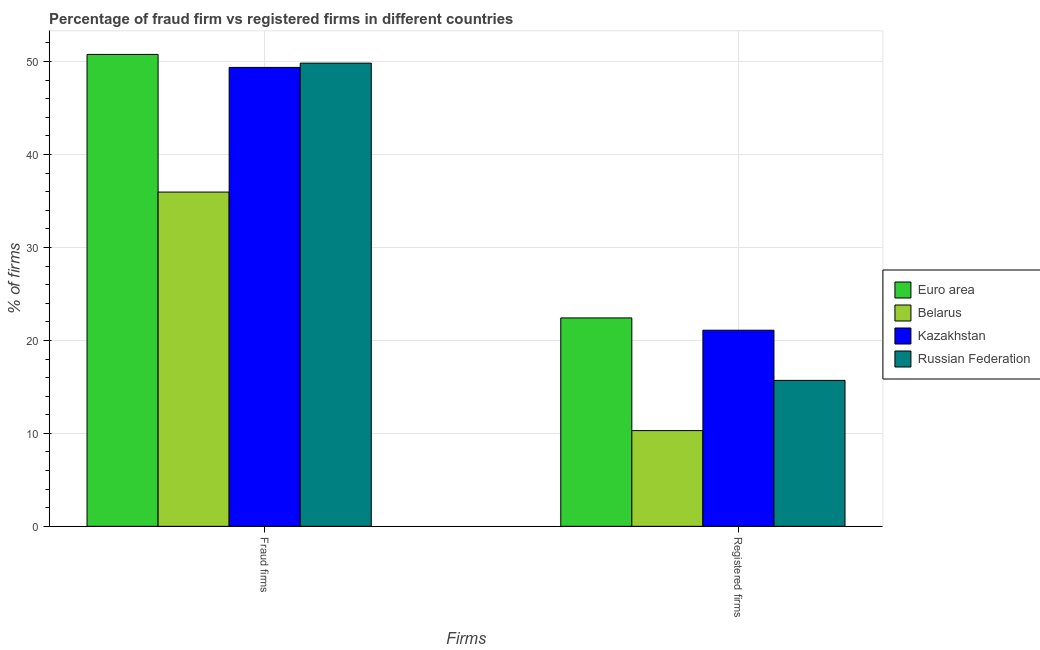How many different coloured bars are there?
Provide a succinct answer. 4. How many groups of bars are there?
Provide a short and direct response. 2. Are the number of bars per tick equal to the number of legend labels?
Provide a succinct answer. Yes. How many bars are there on the 1st tick from the left?
Keep it short and to the point. 4. What is the label of the 1st group of bars from the left?
Provide a short and direct response. Fraud firms. What is the percentage of fraud firms in Belarus?
Your answer should be compact. 35.96. Across all countries, what is the maximum percentage of fraud firms?
Your answer should be compact. 50.77. Across all countries, what is the minimum percentage of fraud firms?
Your answer should be very brief. 35.96. In which country was the percentage of fraud firms maximum?
Give a very brief answer. Euro area. In which country was the percentage of registered firms minimum?
Your answer should be very brief. Belarus. What is the total percentage of registered firms in the graph?
Keep it short and to the point. 69.52. What is the difference between the percentage of fraud firms in Belarus and the percentage of registered firms in Kazakhstan?
Offer a very short reply. 14.86. What is the average percentage of fraud firms per country?
Your response must be concise. 46.48. What is the difference between the percentage of fraud firms and percentage of registered firms in Euro area?
Your answer should be compact. 28.35. In how many countries, is the percentage of registered firms greater than 26 %?
Keep it short and to the point. 0. What is the ratio of the percentage of registered firms in Belarus to that in Kazakhstan?
Ensure brevity in your answer.  0.49. In how many countries, is the percentage of fraud firms greater than the average percentage of fraud firms taken over all countries?
Provide a succinct answer. 3. What does the 3rd bar from the left in Fraud firms represents?
Provide a short and direct response. Kazakhstan. What does the 3rd bar from the right in Registered firms represents?
Give a very brief answer. Belarus. Are all the bars in the graph horizontal?
Make the answer very short. No. How many countries are there in the graph?
Offer a very short reply. 4. Are the values on the major ticks of Y-axis written in scientific E-notation?
Your response must be concise. No. Does the graph contain any zero values?
Offer a very short reply. No. Where does the legend appear in the graph?
Your response must be concise. Center right. How are the legend labels stacked?
Your answer should be very brief. Vertical. What is the title of the graph?
Ensure brevity in your answer.  Percentage of fraud firm vs registered firms in different countries. Does "Syrian Arab Republic" appear as one of the legend labels in the graph?
Provide a succinct answer. No. What is the label or title of the X-axis?
Offer a terse response. Firms. What is the label or title of the Y-axis?
Offer a terse response. % of firms. What is the % of firms in Euro area in Fraud firms?
Keep it short and to the point. 50.77. What is the % of firms in Belarus in Fraud firms?
Give a very brief answer. 35.96. What is the % of firms of Kazakhstan in Fraud firms?
Your response must be concise. 49.37. What is the % of firms in Russian Federation in Fraud firms?
Provide a short and direct response. 49.83. What is the % of firms in Euro area in Registered firms?
Keep it short and to the point. 22.42. What is the % of firms in Belarus in Registered firms?
Offer a very short reply. 10.3. What is the % of firms of Kazakhstan in Registered firms?
Offer a very short reply. 21.1. What is the % of firms of Russian Federation in Registered firms?
Keep it short and to the point. 15.7. Across all Firms, what is the maximum % of firms of Euro area?
Offer a terse response. 50.77. Across all Firms, what is the maximum % of firms of Belarus?
Your answer should be very brief. 35.96. Across all Firms, what is the maximum % of firms of Kazakhstan?
Provide a short and direct response. 49.37. Across all Firms, what is the maximum % of firms in Russian Federation?
Ensure brevity in your answer.  49.83. Across all Firms, what is the minimum % of firms of Euro area?
Your answer should be very brief. 22.42. Across all Firms, what is the minimum % of firms of Belarus?
Provide a short and direct response. 10.3. Across all Firms, what is the minimum % of firms of Kazakhstan?
Keep it short and to the point. 21.1. Across all Firms, what is the minimum % of firms in Russian Federation?
Offer a terse response. 15.7. What is the total % of firms in Euro area in the graph?
Make the answer very short. 73.19. What is the total % of firms in Belarus in the graph?
Your answer should be compact. 46.26. What is the total % of firms in Kazakhstan in the graph?
Provide a short and direct response. 70.47. What is the total % of firms of Russian Federation in the graph?
Give a very brief answer. 65.53. What is the difference between the % of firms of Euro area in Fraud firms and that in Registered firms?
Your response must be concise. 28.35. What is the difference between the % of firms in Belarus in Fraud firms and that in Registered firms?
Offer a very short reply. 25.66. What is the difference between the % of firms of Kazakhstan in Fraud firms and that in Registered firms?
Keep it short and to the point. 28.27. What is the difference between the % of firms in Russian Federation in Fraud firms and that in Registered firms?
Ensure brevity in your answer.  34.13. What is the difference between the % of firms in Euro area in Fraud firms and the % of firms in Belarus in Registered firms?
Make the answer very short. 40.47. What is the difference between the % of firms of Euro area in Fraud firms and the % of firms of Kazakhstan in Registered firms?
Your response must be concise. 29.67. What is the difference between the % of firms of Euro area in Fraud firms and the % of firms of Russian Federation in Registered firms?
Offer a terse response. 35.07. What is the difference between the % of firms of Belarus in Fraud firms and the % of firms of Kazakhstan in Registered firms?
Your response must be concise. 14.86. What is the difference between the % of firms in Belarus in Fraud firms and the % of firms in Russian Federation in Registered firms?
Give a very brief answer. 20.26. What is the difference between the % of firms of Kazakhstan in Fraud firms and the % of firms of Russian Federation in Registered firms?
Provide a short and direct response. 33.67. What is the average % of firms in Euro area per Firms?
Make the answer very short. 36.59. What is the average % of firms in Belarus per Firms?
Your response must be concise. 23.13. What is the average % of firms in Kazakhstan per Firms?
Offer a terse response. 35.23. What is the average % of firms of Russian Federation per Firms?
Offer a terse response. 32.77. What is the difference between the % of firms in Euro area and % of firms in Belarus in Fraud firms?
Offer a very short reply. 14.81. What is the difference between the % of firms of Euro area and % of firms of Kazakhstan in Fraud firms?
Provide a short and direct response. 1.4. What is the difference between the % of firms of Euro area and % of firms of Russian Federation in Fraud firms?
Provide a succinct answer. 0.94. What is the difference between the % of firms of Belarus and % of firms of Kazakhstan in Fraud firms?
Give a very brief answer. -13.41. What is the difference between the % of firms in Belarus and % of firms in Russian Federation in Fraud firms?
Offer a very short reply. -13.87. What is the difference between the % of firms of Kazakhstan and % of firms of Russian Federation in Fraud firms?
Make the answer very short. -0.46. What is the difference between the % of firms in Euro area and % of firms in Belarus in Registered firms?
Your answer should be compact. 12.12. What is the difference between the % of firms in Euro area and % of firms in Kazakhstan in Registered firms?
Ensure brevity in your answer.  1.32. What is the difference between the % of firms in Euro area and % of firms in Russian Federation in Registered firms?
Your response must be concise. 6.72. What is the difference between the % of firms of Kazakhstan and % of firms of Russian Federation in Registered firms?
Keep it short and to the point. 5.4. What is the ratio of the % of firms in Euro area in Fraud firms to that in Registered firms?
Keep it short and to the point. 2.26. What is the ratio of the % of firms of Belarus in Fraud firms to that in Registered firms?
Your answer should be very brief. 3.49. What is the ratio of the % of firms of Kazakhstan in Fraud firms to that in Registered firms?
Offer a terse response. 2.34. What is the ratio of the % of firms in Russian Federation in Fraud firms to that in Registered firms?
Give a very brief answer. 3.17. What is the difference between the highest and the second highest % of firms in Euro area?
Keep it short and to the point. 28.35. What is the difference between the highest and the second highest % of firms in Belarus?
Your answer should be compact. 25.66. What is the difference between the highest and the second highest % of firms in Kazakhstan?
Provide a succinct answer. 28.27. What is the difference between the highest and the second highest % of firms of Russian Federation?
Give a very brief answer. 34.13. What is the difference between the highest and the lowest % of firms of Euro area?
Your answer should be very brief. 28.35. What is the difference between the highest and the lowest % of firms of Belarus?
Provide a short and direct response. 25.66. What is the difference between the highest and the lowest % of firms in Kazakhstan?
Your response must be concise. 28.27. What is the difference between the highest and the lowest % of firms of Russian Federation?
Your response must be concise. 34.13. 